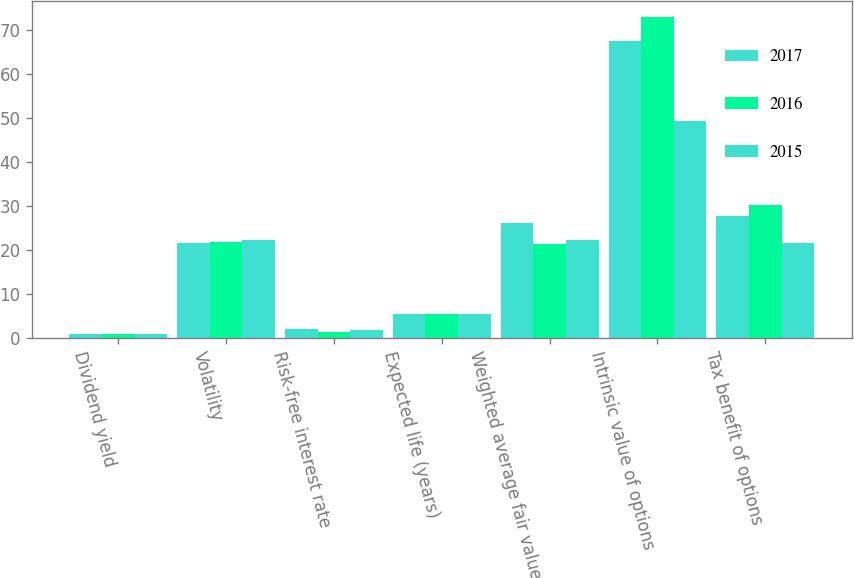Convert chart. <chart><loc_0><loc_0><loc_500><loc_500><stacked_bar_chart><ecel><fcel>Dividend yield<fcel>Volatility<fcel>Risk-free interest rate<fcel>Expected life (years)<fcel>Weighted average fair value of<fcel>Intrinsic value of options<fcel>Tax benefit of options<nl><fcel>2017<fcel>0.8<fcel>21.6<fcel>2<fcel>5.3<fcel>26.09<fcel>67.6<fcel>27.7<nl><fcel>2016<fcel>0.9<fcel>21.9<fcel>1.4<fcel>5.3<fcel>21.3<fcel>73<fcel>30.1<nl><fcel>2015<fcel>0.8<fcel>22.2<fcel>1.7<fcel>5.3<fcel>22.3<fcel>49.4<fcel>21.45<nl></chart> 